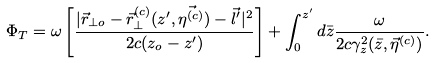Convert formula to latex. <formula><loc_0><loc_0><loc_500><loc_500>\Phi _ { T } = \omega \left [ \frac { | \vec { r } _ { \bot o } - \vec { r } ^ { ( c ) } _ { \bot } ( z ^ { \prime } , \vec { \eta ^ { ( c ) } } ) - \vec { l } ^ { \prime } | ^ { 2 } } { 2 c ( z _ { o } - z ^ { \prime } ) } \right ] + \int _ { 0 } ^ { z ^ { \prime } } d \bar { z } \frac { \omega } { 2 c \gamma _ { z } ^ { 2 } ( \bar { z } , \vec { \eta } ^ { ( c ) } ) } .</formula> 